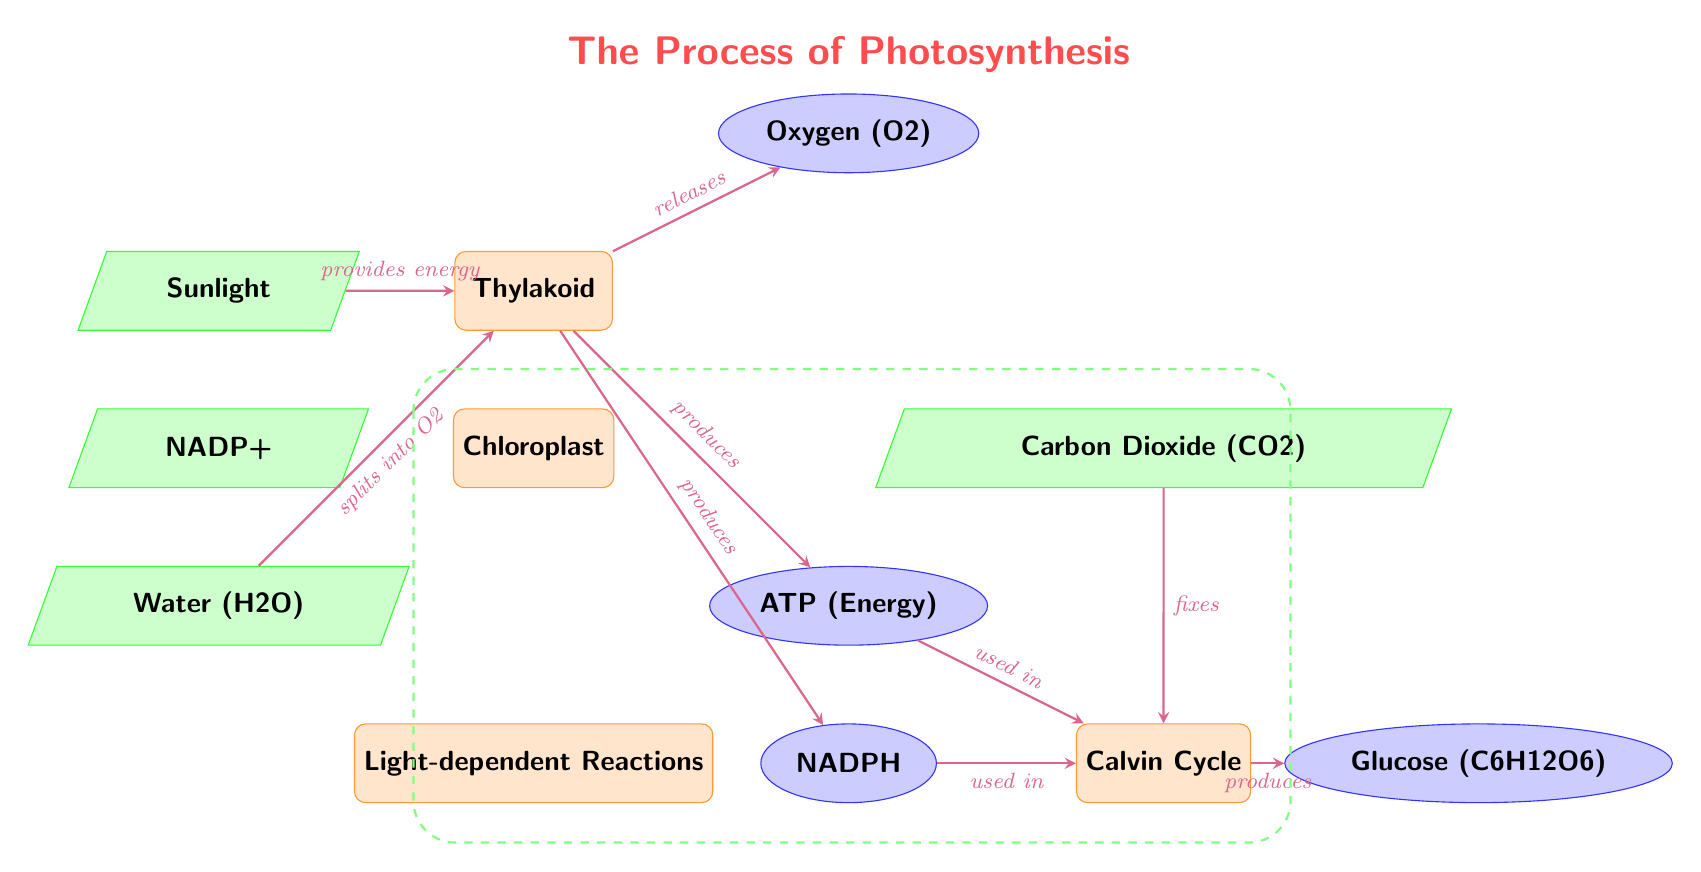What's the input that provides energy in the diagram? The diagram indicates that sunlight serves as the input that provides energy to the thylakoid. Therefore, the answer is sunlight.
Answer: sunlight How many outputs are produced in the light-dependent reactions? From the diagram, it shows three outputs produced in the light-dependent reactions: oxygen, ATP, and NADPH. Thus, the answer is three.
Answer: three What is released from the thylakoid as water splits? The diagram specifies that when water splits in the thylakoid, oxygen is released. Therefore, the answer is oxygen.
Answer: oxygen Which molecule is used in the Calvin cycle? The diagram illustrates that both NADPH and ATP are used in the Calvin cycle. The answer refers to the first mentioned in the diagram as NADPH.
Answer: NADPH What does the Calvin cycle produce? According to the diagram, the Calvin cycle produces glucose as its end product, which is explicitly stated. Therefore, the answer is glucose.
Answer: glucose What is the role of carbon dioxide in the process? The diagram shows that carbon dioxide is fixed in the Calvin cycle, indicating its essential role in the process. Thus, the answer is fixes.
Answer: fixes What are the inputs needed for light-dependent reactions? Based on the diagram, the inputs for the light-dependent reactions are sunlight, water, and NADP+. Hence, the answer is sunlight, water, and NADP+.
Answer: sunlight, water, NADP+ Which part of the chloroplast is involved in light-dependent reactions? The diagram indicates that the thylakoid is the specific part of the chloroplast that is involved in the light-dependent reactions. Therefore, the answer is thylakoid.
Answer: thylakoid 